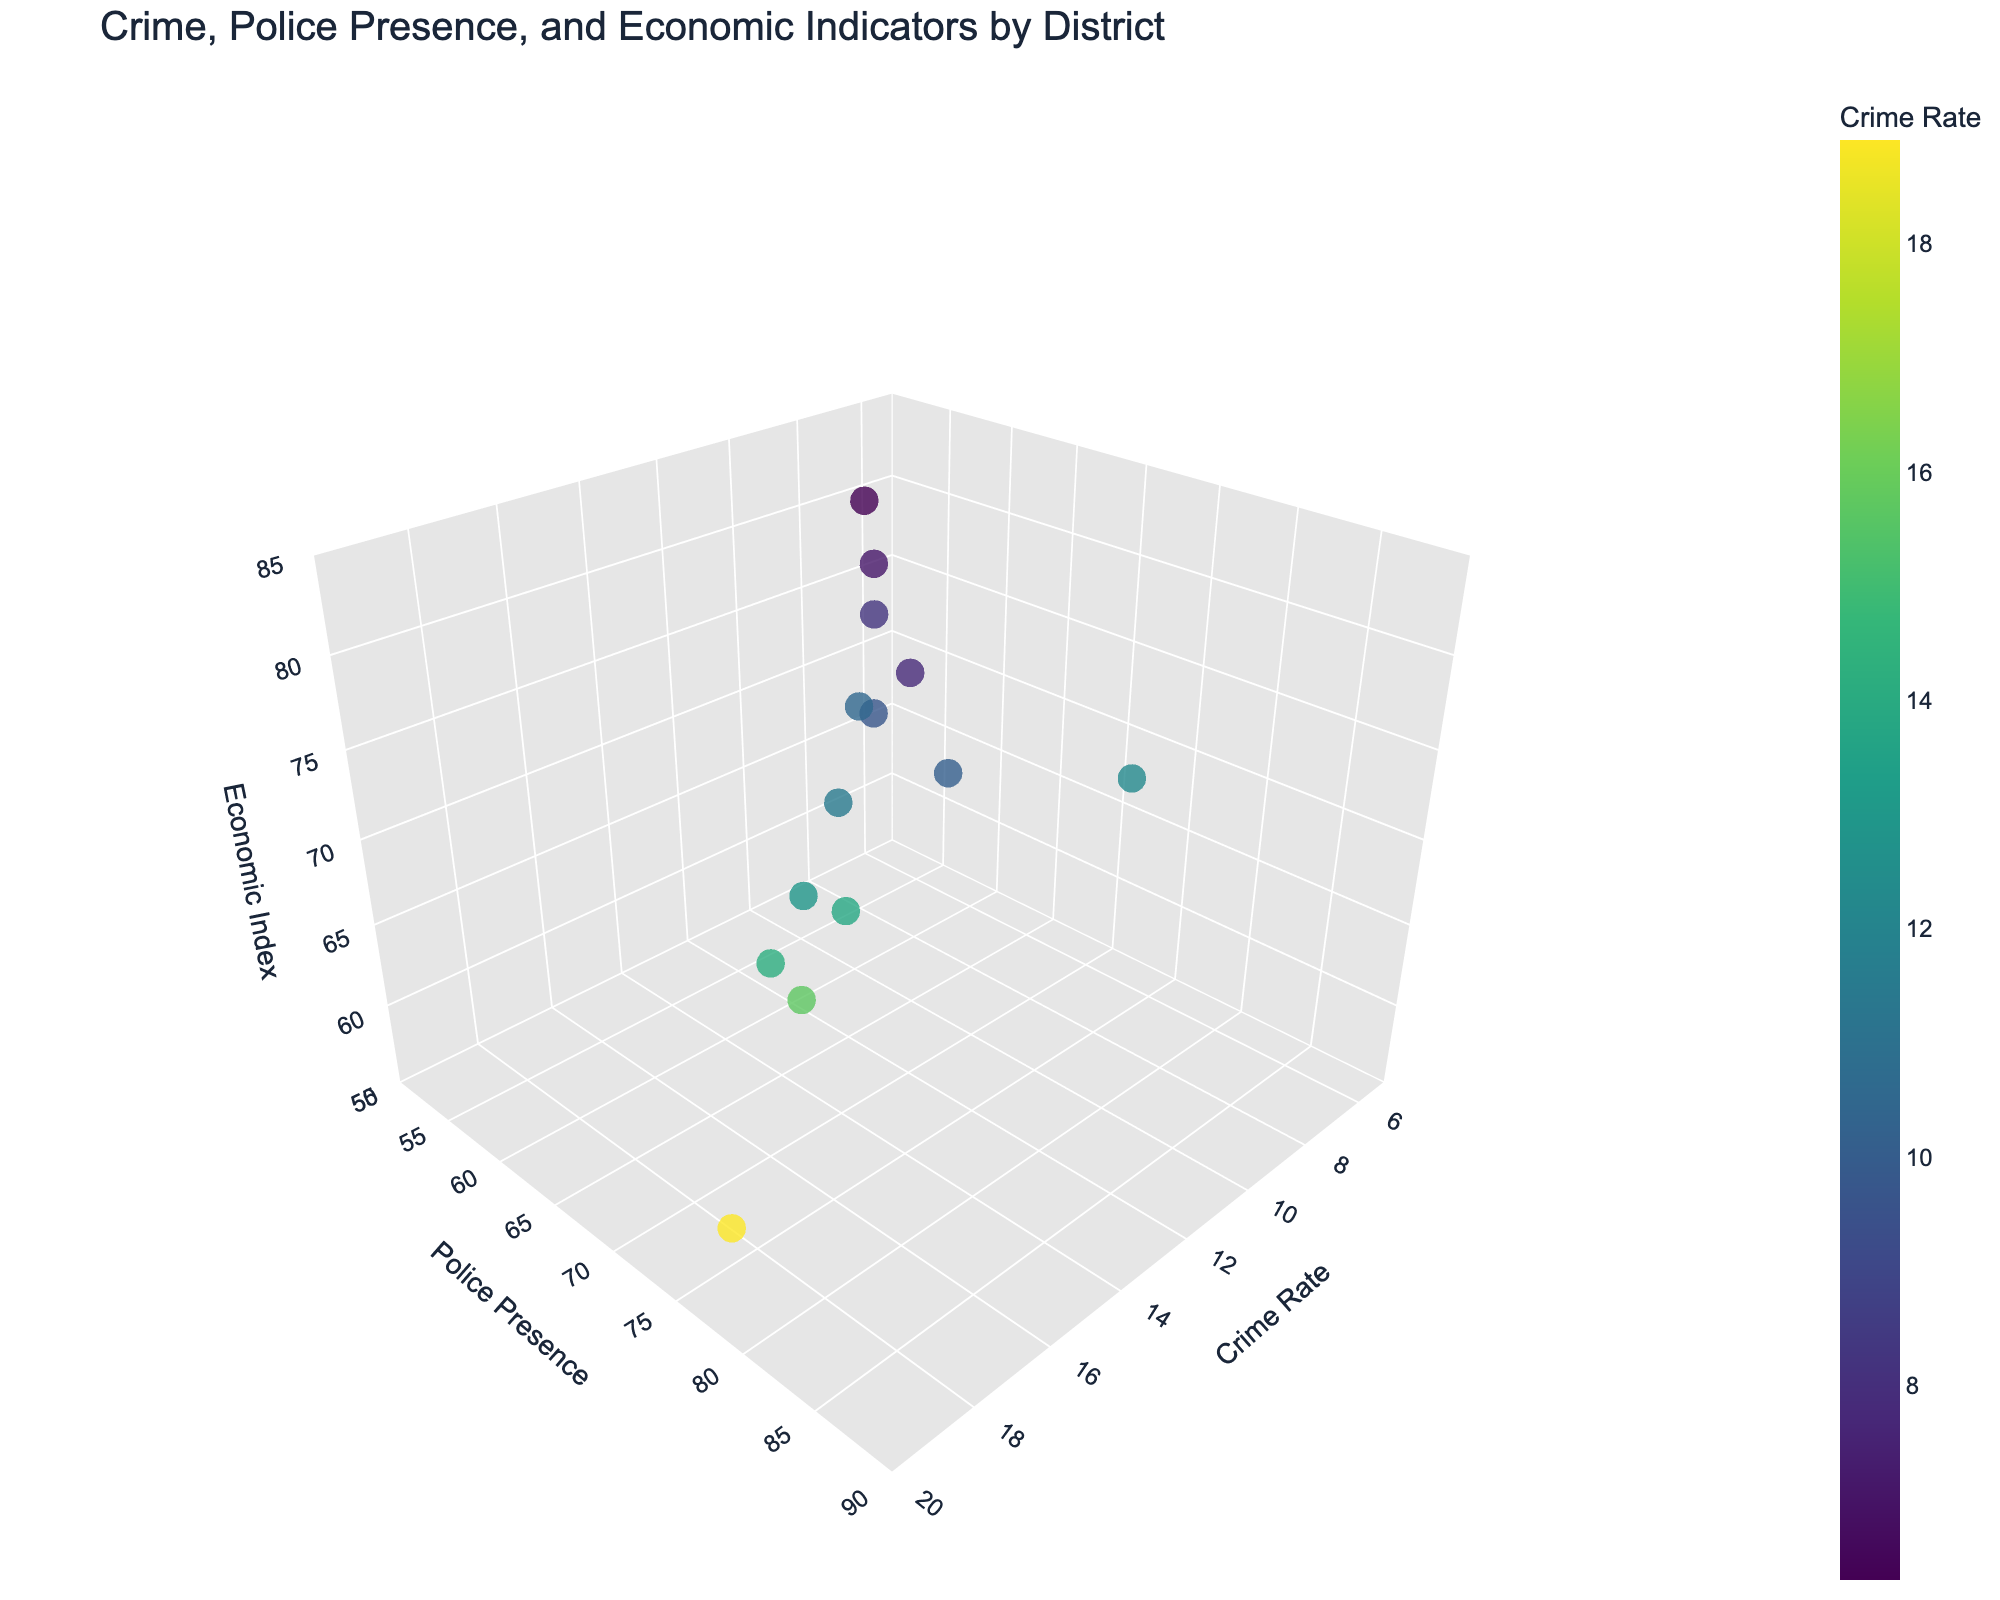How many districts are represented in the figure? By observing the data points in the 3D scatter plot, you can count the total number of unique points to determine the number of districts represented.
Answer: 14 What is the district with the highest crime rate? By looking at the 'Crime Rate' axis, identify the point that is farthest along the positive direction on this axis, which corresponds to the district with the highest crime rate.
Answer: Bronx Which district has the highest economic index? By examining the 'Economic Index' axis, find the data point that is highest on this axis, indicating the district with the highest economic index.
Answer: Oyster Bay Is there a district with both low crime rate and high police presence? To answer this, locate districts in the plot that are on the lower end of the 'Crime Rate' axis while also being on the higher end of the 'Police Presence' axis.
Answer: Yes (Example: Glen Cove) Which district has the lowest police presence, and what is its corresponding economic index? By identifying the data point on the lowest end of the 'Police Presence' axis, check the corresponding value on the 'Economic Index' axis for this district.
Answer: Oyster Bay, 79.5 What is the average crime rate of all districts? Sum all the crime rates from the data provided and divide by the number of districts (14). (12.3 + 15.7 + 10.1 + 18.9 + 7.8 + 11.5 + 8.2 + 9.7 + 14.2 + 13.8 + 12.9 + 10.5 + 7.1 + 6.3)/14 = 146.0/14 = 10.43 approx.
Answer: 10.43 Which two districts have the closest economic index values, and what are those values? Looking at the 'Economic Index' values, identify the two districts whose values are closest to each other by calculating the differences and finding the minimum difference.
Answer: Glen Cove (76.9) and Manhattan (78.5) Do districts with higher police presence generally have higher or lower economic indexes? Provide a general trend. By observing the correlation in the 3D plot between 'Police Presence' and ‘Economic Index’, determine if districts with high police presence points tend to fall in the higher or lower end of the 'Economic Index' axis.
Answer: Higher Which district has a moderate crime rate (around 10-15), high police presence (above 70), and an economic index around 65-75? By filtering the points in the 3D scatter plot based on these criteria for moderate crime rate, high police presence, and a specific range in economic index, find the district that satisfies all these conditions.
Answer: Brooklyn How does police presence correlate with crime rate according to the visualization? Analyzing the general direction and clustering of points on the 'Crime Rate' and 'Police Presence' axes in the 3D scatter plot can show if there is a positive or negative correlation.
Answer: No clear correlation 